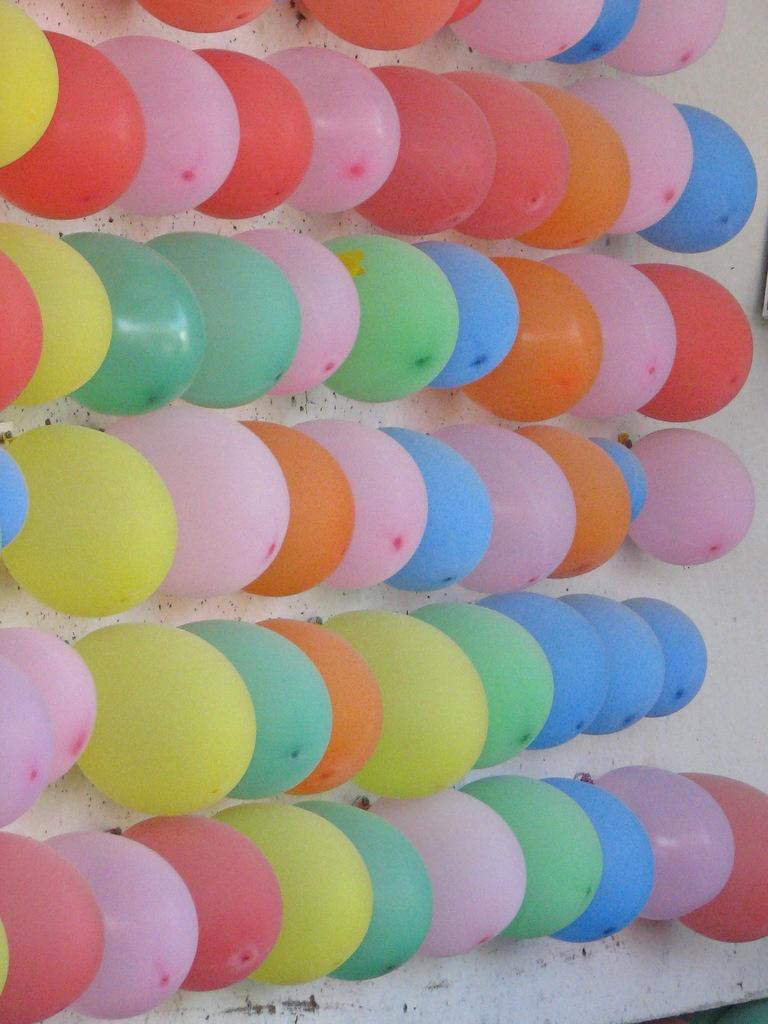What is the main object in the image? There is a board in the image. What is attached to the board? There are balloons on the board. What type of copper material is used to make the board in the image? There is no mention of copper or any specific material used to make the board in the image. Can you see a robin perched on the board in the image? There is no robin or any bird visible on the board in the image. 